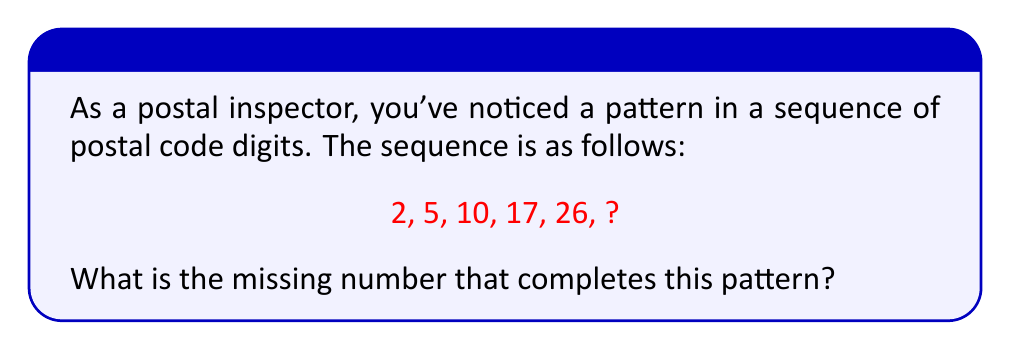Can you answer this question? Let's analyze the sequence step by step:

1) First, let's look at the differences between consecutive terms:
   $2 \rightarrow 5$ (difference of 3)
   $5 \rightarrow 10$ (difference of 5)
   $10 \rightarrow 17$ (difference of 7)
   $17 \rightarrow 26$ (difference of 9)

2) We can see that the differences are increasing by 2 each time:
   3, 5, 7, 9

3) This suggests that the next difference will be 11.

4) Therefore, to find the missing number, we add 11 to the last given number in the sequence:

   $26 + 11 = 37$

5) We can verify this by looking at the general term of the sequence:
   
   The nth term of this sequence can be expressed as:
   
   $a_n = n^2 + 1$

   Let's check:
   $1^2 + 1 = 2$
   $2^2 + 1 = 5$
   $3^2 + 1 = 10$
   $4^2 + 1 = 17$
   $5^2 + 1 = 26$
   $6^2 + 1 = 37$

Therefore, the missing number that completes the pattern is 37.
Answer: 37 